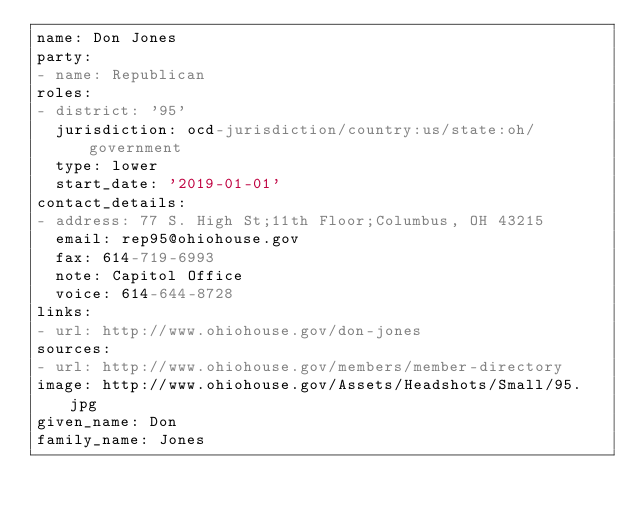<code> <loc_0><loc_0><loc_500><loc_500><_YAML_>name: Don Jones
party:
- name: Republican
roles:
- district: '95'
  jurisdiction: ocd-jurisdiction/country:us/state:oh/government
  type: lower
  start_date: '2019-01-01'
contact_details:
- address: 77 S. High St;11th Floor;Columbus, OH 43215
  email: rep95@ohiohouse.gov
  fax: 614-719-6993
  note: Capitol Office
  voice: 614-644-8728
links:
- url: http://www.ohiohouse.gov/don-jones
sources:
- url: http://www.ohiohouse.gov/members/member-directory
image: http://www.ohiohouse.gov/Assets/Headshots/Small/95.jpg
given_name: Don
family_name: Jones
</code> 